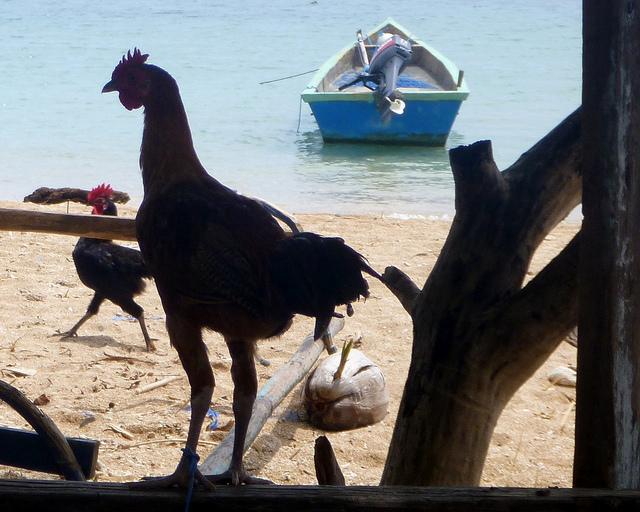How many giraffes are in the photo?
Short answer required. 0. What is in the water?
Answer briefly. Boat. Where is the elevated motor?
Concise answer only. On boat. 